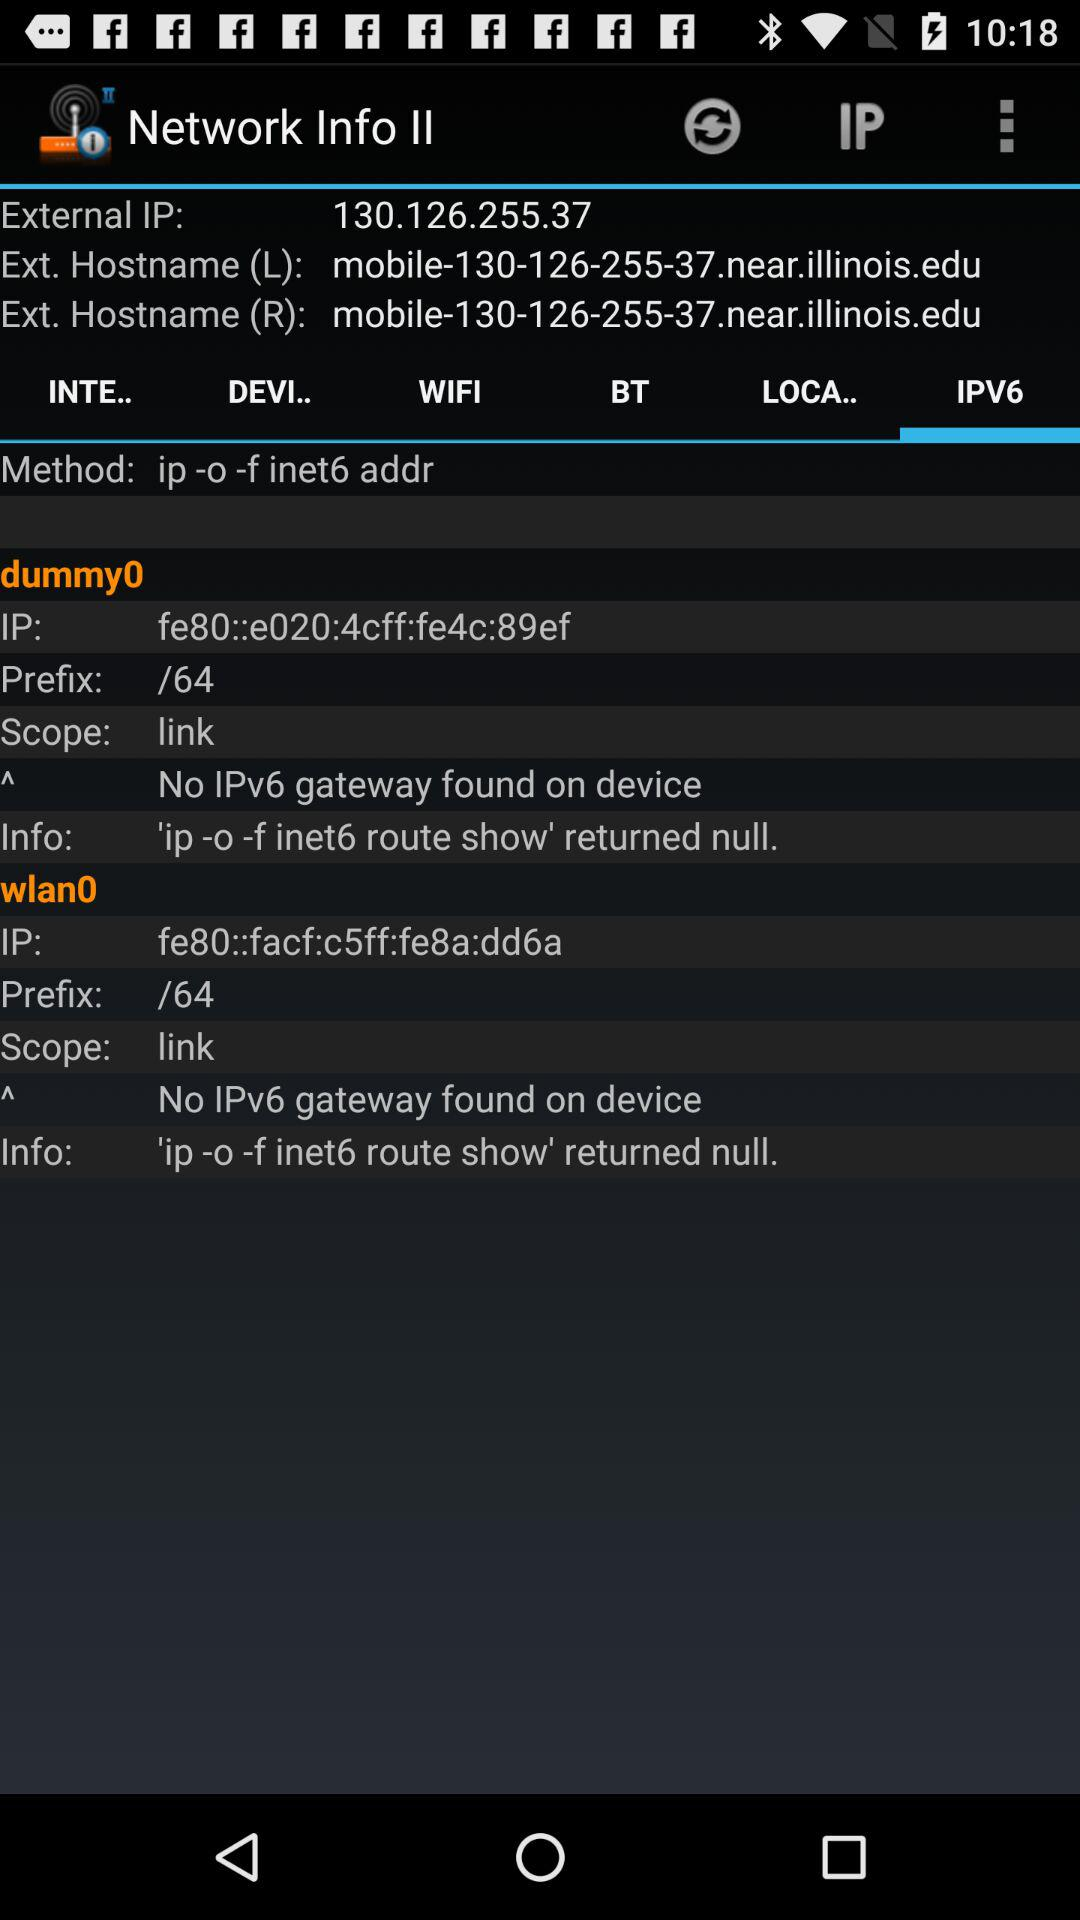Which tab of "Network Info II" is selected? The selected tab is "IPV6". 